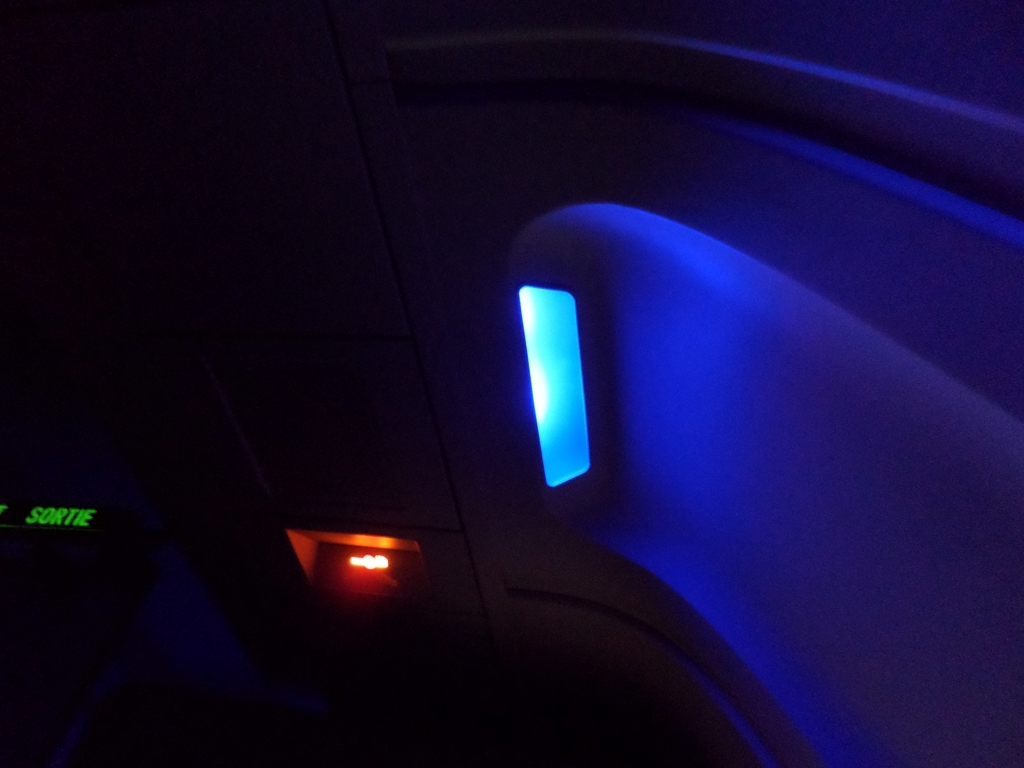What do you think is the purpose of the blue light in this setting? The blue light in this image seems to serve as ambient lighting, which is often used in airplane cabins to help create a sense of calm during a flight and possibly to assist passengers with their acclimatization to the cabin environment during nighttime flights. Does the presence of this light suggest anything about the time of day or stage of the flight? The presence of the blue light, coupled with the surrounding darkness, could suggest that the photo was taken during an evening or night flight. It might indicate that the cabin lights have been dimmed to allow passengers to rest or sleep. 